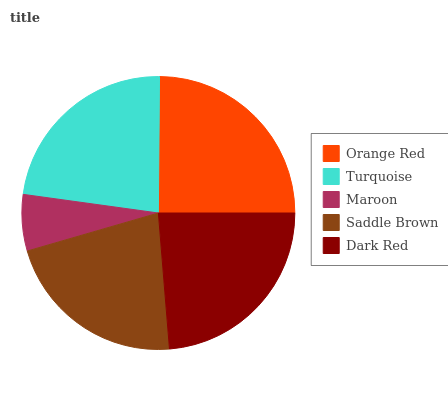Is Maroon the minimum?
Answer yes or no. Yes. Is Orange Red the maximum?
Answer yes or no. Yes. Is Turquoise the minimum?
Answer yes or no. No. Is Turquoise the maximum?
Answer yes or no. No. Is Orange Red greater than Turquoise?
Answer yes or no. Yes. Is Turquoise less than Orange Red?
Answer yes or no. Yes. Is Turquoise greater than Orange Red?
Answer yes or no. No. Is Orange Red less than Turquoise?
Answer yes or no. No. Is Turquoise the high median?
Answer yes or no. Yes. Is Turquoise the low median?
Answer yes or no. Yes. Is Dark Red the high median?
Answer yes or no. No. Is Maroon the low median?
Answer yes or no. No. 